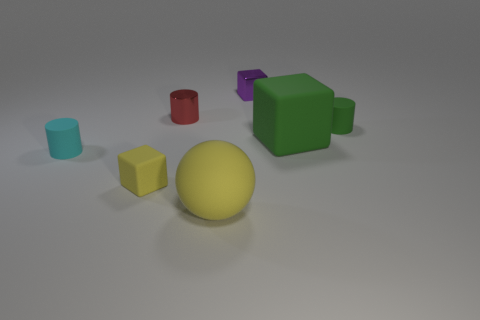What shape is the large yellow object that is made of the same material as the big block?
Keep it short and to the point. Sphere. Does the big rubber thing in front of the cyan matte object have the same shape as the small purple metal object?
Your answer should be very brief. No. What number of objects are large red cubes or yellow matte balls?
Your response must be concise. 1. There is a object that is in front of the small cyan matte cylinder and behind the large yellow ball; what material is it made of?
Give a very brief answer. Rubber. Do the metal cylinder and the yellow rubber sphere have the same size?
Provide a succinct answer. No. How big is the green rubber object to the left of the small matte object behind the large green thing?
Your response must be concise. Large. How many objects are to the left of the large yellow rubber sphere and in front of the big green matte block?
Offer a very short reply. 2. There is a rubber cylinder that is right of the block on the left side of the small metallic block; is there a purple thing right of it?
Offer a very short reply. No. What shape is the rubber object that is the same size as the yellow ball?
Provide a short and direct response. Cube. Are there any tiny matte things that have the same color as the matte ball?
Give a very brief answer. Yes. 